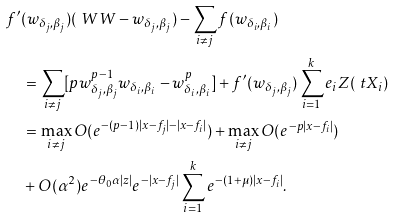<formula> <loc_0><loc_0><loc_500><loc_500>& f ^ { \prime } ( w _ { \delta _ { j } , \beta _ { j } } ) ( \ W W - w _ { \delta _ { j } , \beta _ { j } } ) - \sum _ { i \neq j } f ( w _ { \delta _ { i } , \beta _ { i } } ) \\ & \quad = \sum _ { i \neq j } [ p w _ { \delta _ { j } , \beta _ { j } } ^ { p - 1 } w _ { \delta _ { i } , \beta _ { i } } - w _ { \delta _ { i } , \beta _ { i } } ^ { p } ] + f ^ { \prime } ( w _ { \delta _ { j } , \beta _ { j } } ) \sum _ { i = 1 } ^ { k } e _ { i } Z ( \ t X _ { i } ) \\ & \quad = \max _ { i \neq j } O ( e ^ { \, - ( p - 1 ) | x - f _ { j } | - | x - f _ { i } | } ) + \max _ { i \neq j } O ( e ^ { \, - p | x - f _ { i } | } ) \\ & \quad + O ( \alpha ^ { 2 } ) e ^ { \, - \theta _ { 0 } \alpha | z | } e ^ { \, - | x - f _ { j } | } \sum _ { i = 1 } ^ { k } e ^ { \, - ( 1 + \mu ) | x - f _ { i } | } .</formula> 